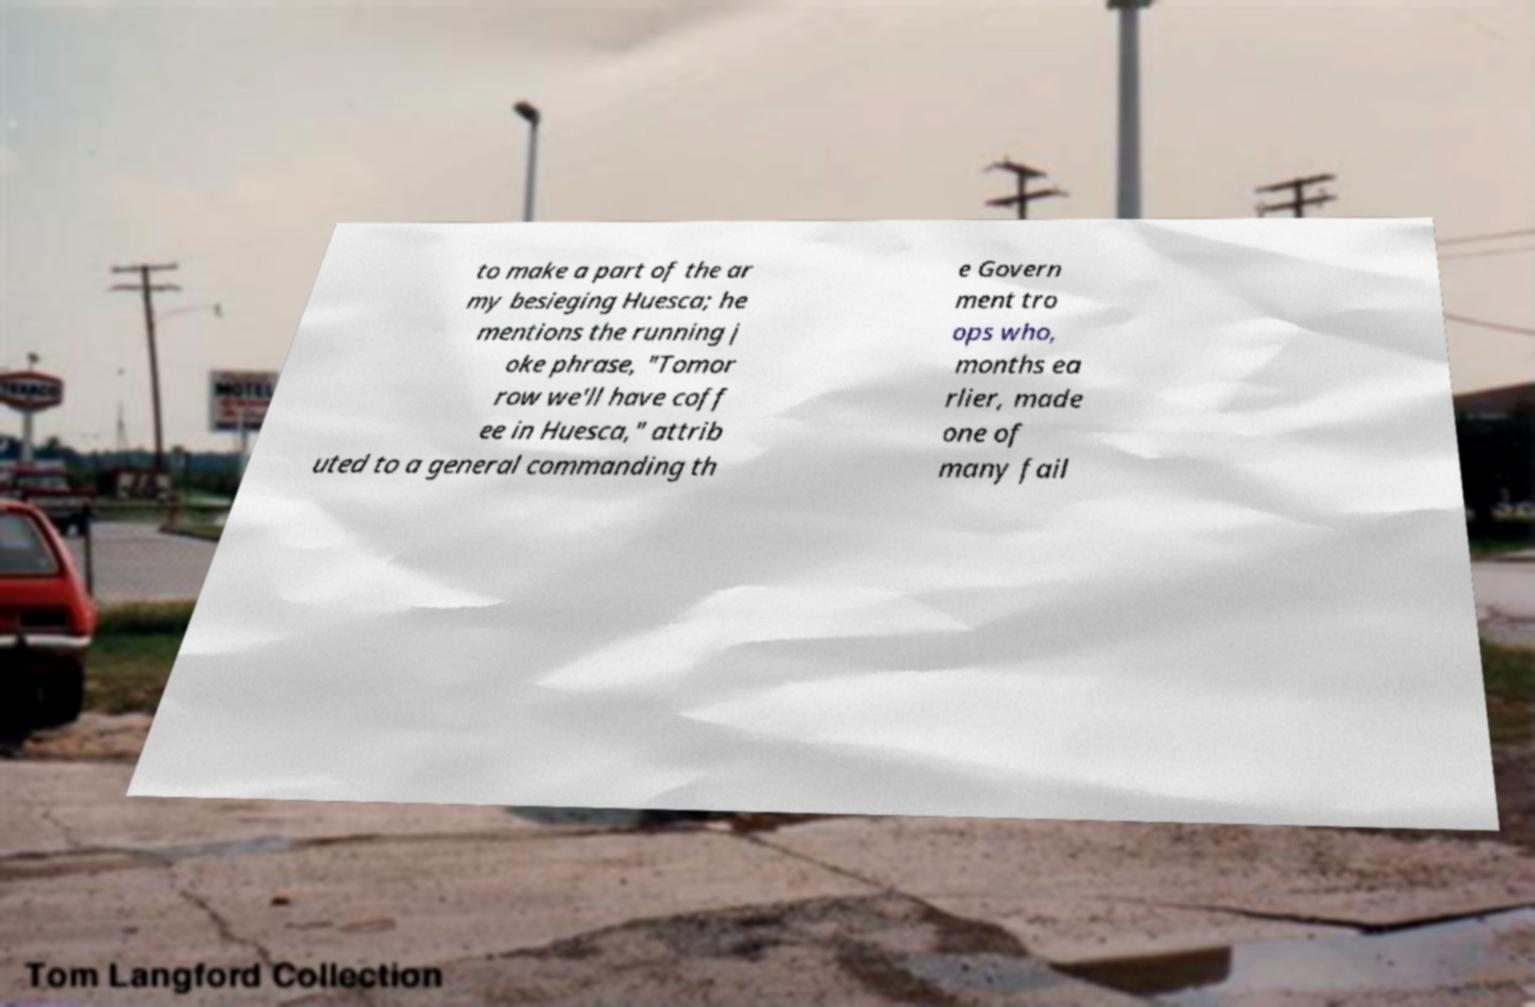Can you read and provide the text displayed in the image?This photo seems to have some interesting text. Can you extract and type it out for me? to make a part of the ar my besieging Huesca; he mentions the running j oke phrase, "Tomor row we'll have coff ee in Huesca," attrib uted to a general commanding th e Govern ment tro ops who, months ea rlier, made one of many fail 